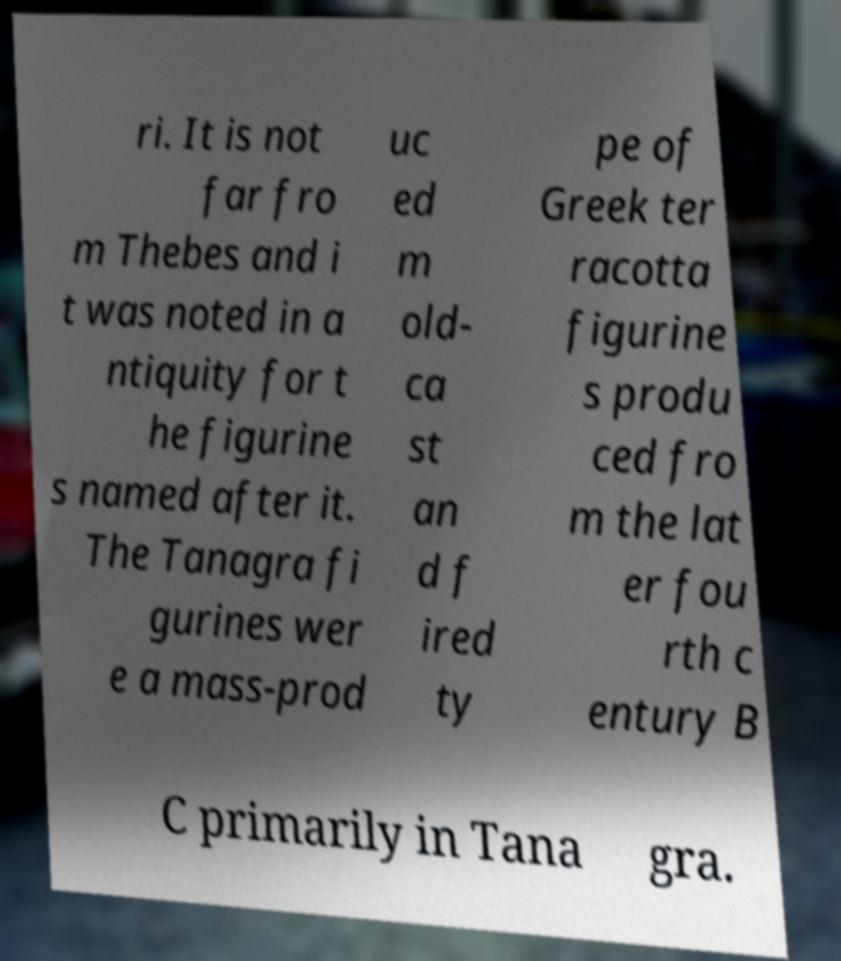Could you assist in decoding the text presented in this image and type it out clearly? ri. It is not far fro m Thebes and i t was noted in a ntiquity for t he figurine s named after it. The Tanagra fi gurines wer e a mass-prod uc ed m old- ca st an d f ired ty pe of Greek ter racotta figurine s produ ced fro m the lat er fou rth c entury B C primarily in Tana gra. 